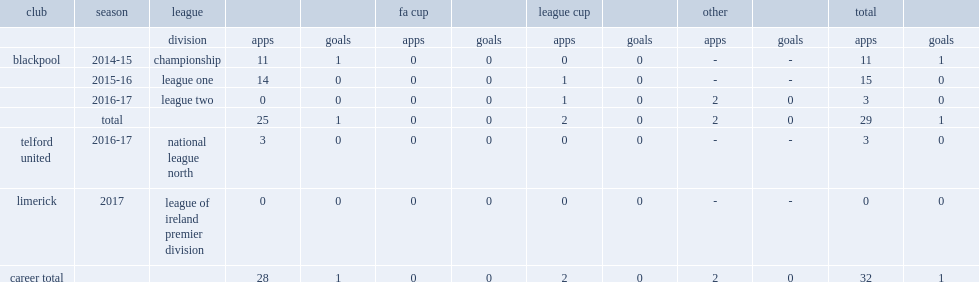Which club did cameron transfer to, in 2017? Limerick. 